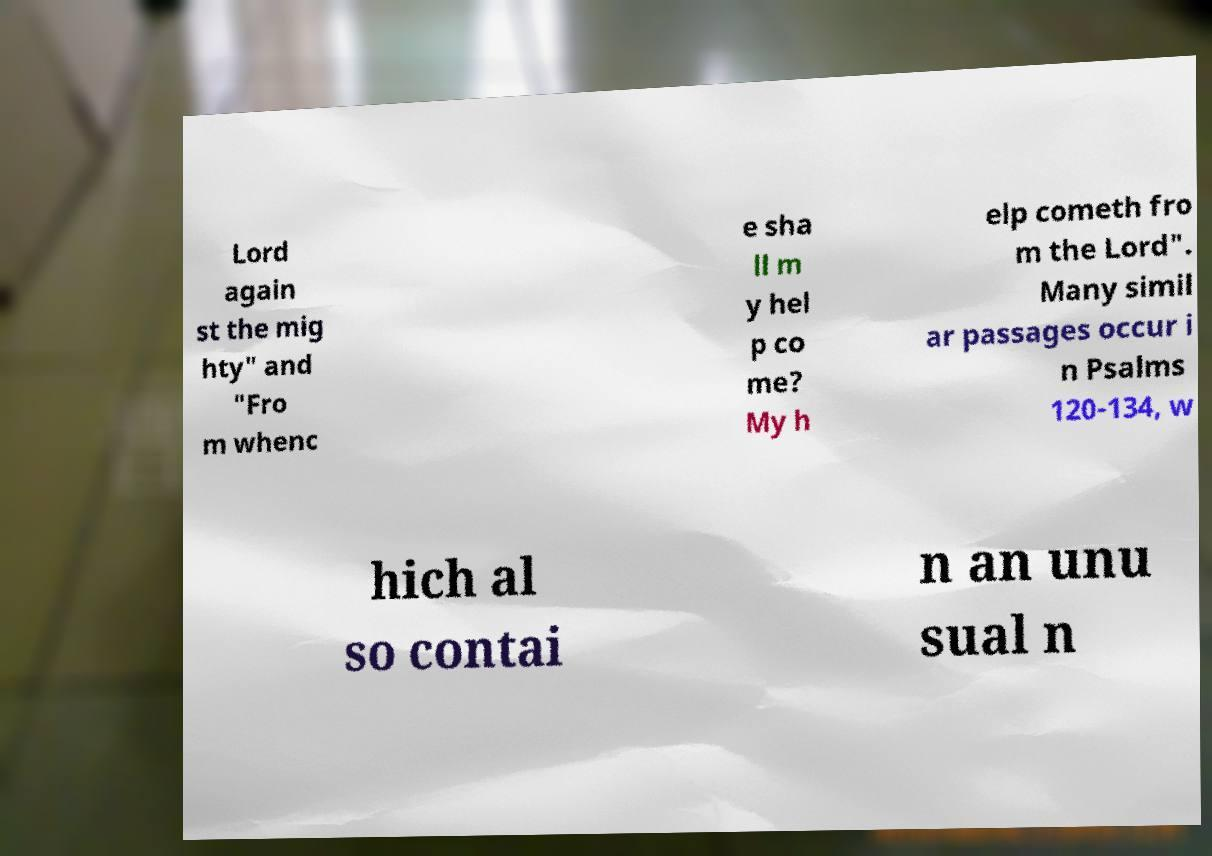What messages or text are displayed in this image? I need them in a readable, typed format. Lord again st the mig hty" and "Fro m whenc e sha ll m y hel p co me? My h elp cometh fro m the Lord". Many simil ar passages occur i n Psalms 120-134, w hich al so contai n an unu sual n 